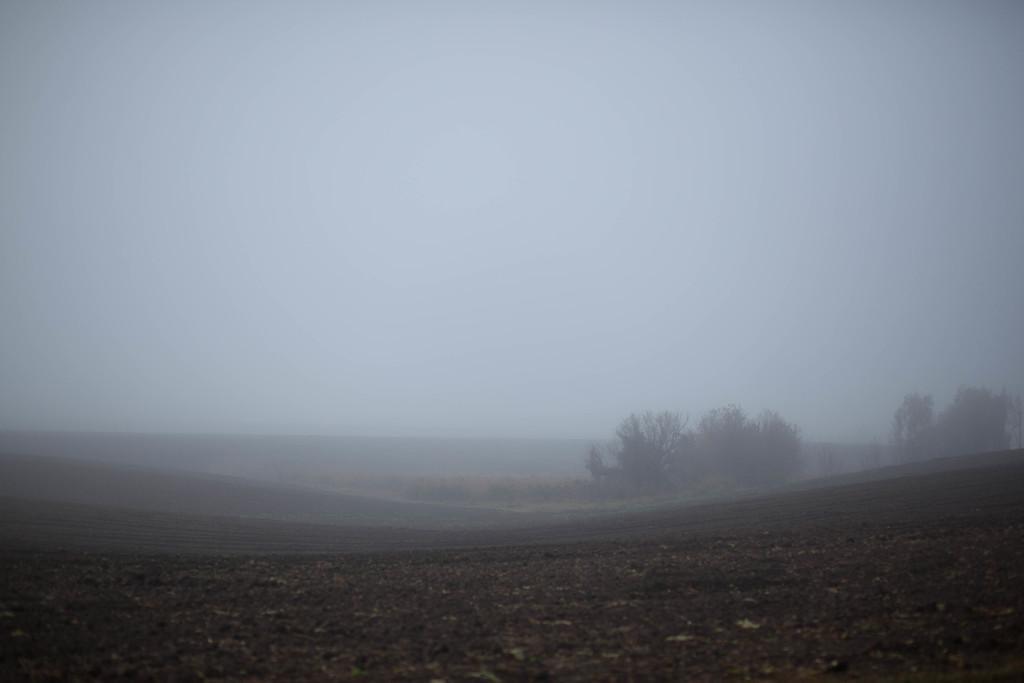Could you give a brief overview of what you see in this image? In the picture I can see the ground, trees, fog and the sky in the background. 